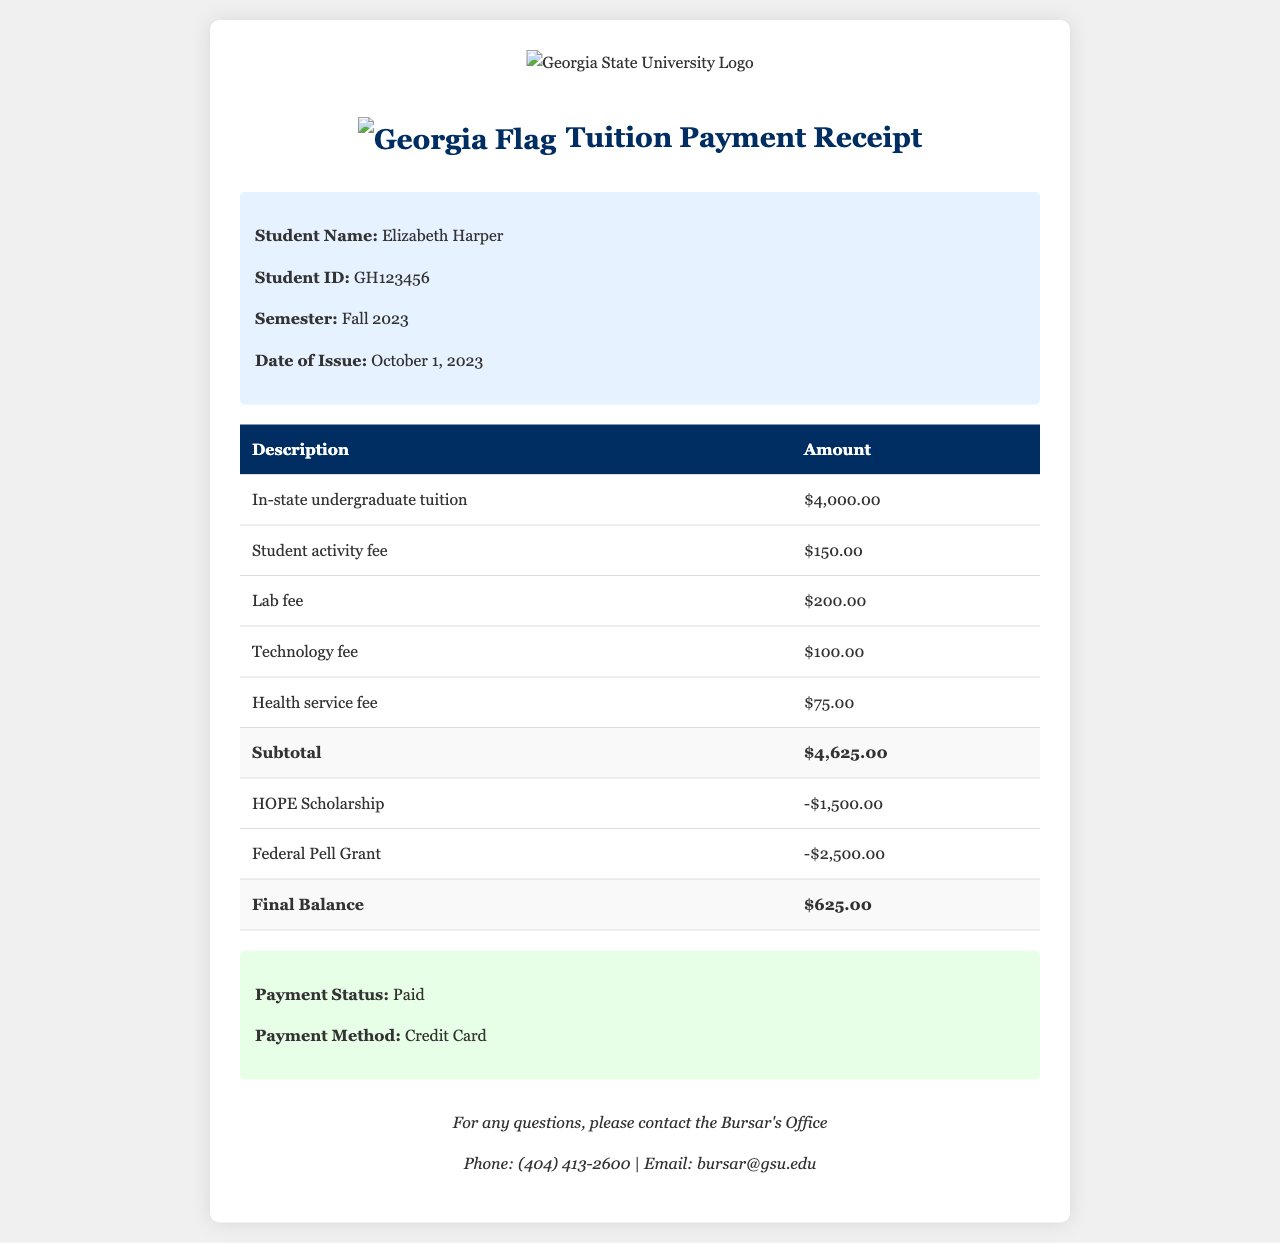What is the student's name? The student's name is provided in the student information section of the document.
Answer: Elizabeth Harper What is the total amount of fees before any scholarships or grants? The subtotal of fees is listed in the fees table, which includes tuition and other fees.
Answer: $4,625.00 What is the final balance after applying scholarships and grants? The final balance is calculated after subtracting scholarships and grants from the subtotal.
Answer: $625.00 What is the amount of the HOPE Scholarship? The amount for the HOPE Scholarship is provided in the fees table as a deduction.
Answer: -$1,500.00 What payment method was used? The document specifies the payment method in the payment information section.
Answer: Credit Card When was the tuition receipt issued? The date of issue is stated in the student information section of the document.
Answer: October 1, 2023 What is the total amount received after applying financial aid? The final payment balance gives an indication of the remaining amount after applying financial aid.
Answer: $625.00 What fees are included in the subtotal? The subtotal includes various fees such as tuition, student activity fee, lab fee, technology fee, and health service fee.
Answer: In-state undergraduate tuition, student activity fee, lab fee, technology fee, health service fee Which office should be contacted for questions regarding the receipt? The contact information for inquiries is listed towards the end of the document.
Answer: Bursar's Office 